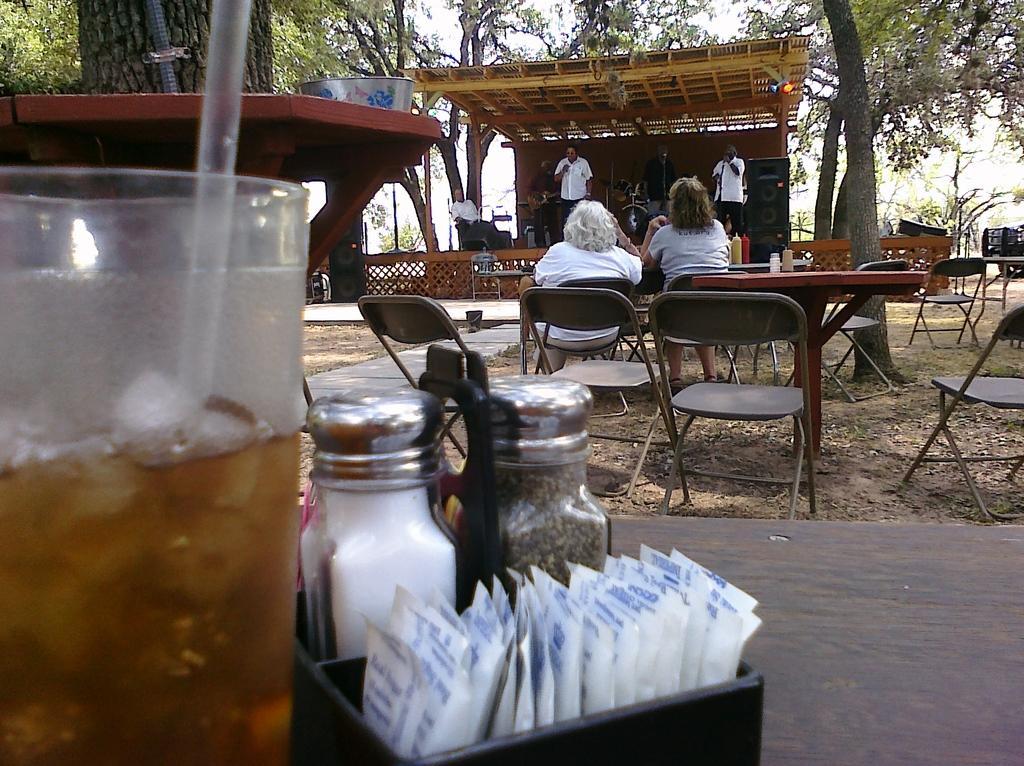Describe this image in one or two sentences. In this picture we see a glass and some objects on the table, and we see group of people some are seated on the chair and some are standing in front of the microphone and we see a sound system and couple of trees. 